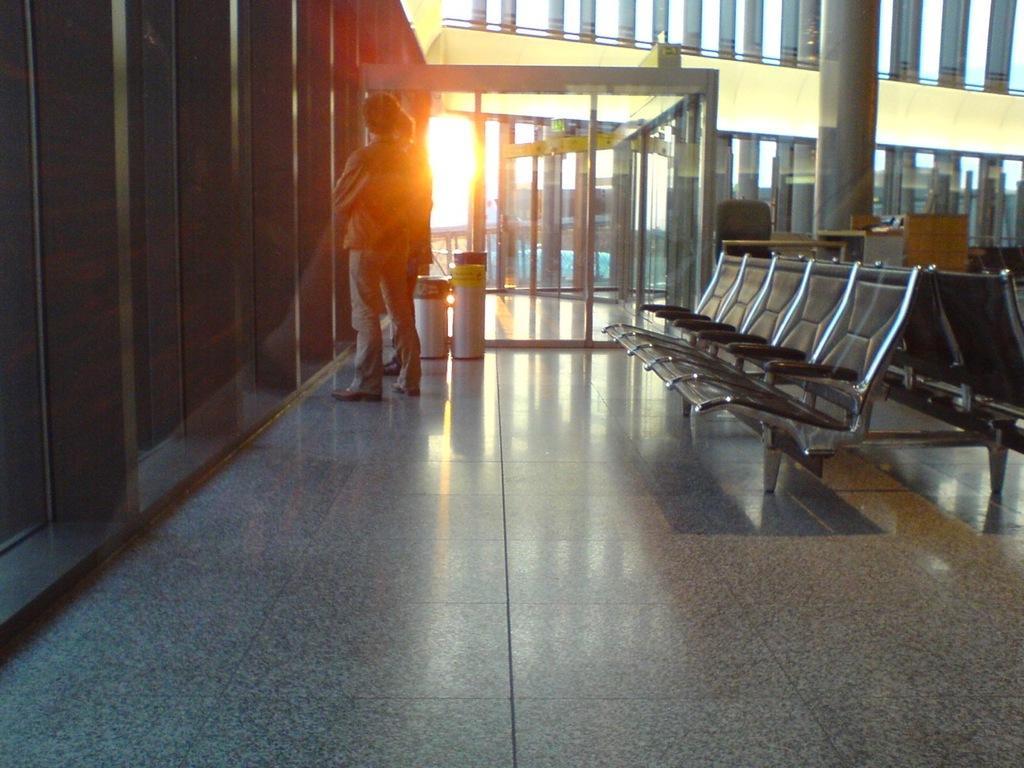Can you describe this image briefly? To the left side of the image there are pillars with glass doors. And in front of them there is a person standing on the floor. Beside the person there is a dustbin and also there are glass doors and sunlight. To the right side of the image there are few chairs. Behind the chairs there is a pole and table with a chair. To the right top top of the image there are glass doors. 